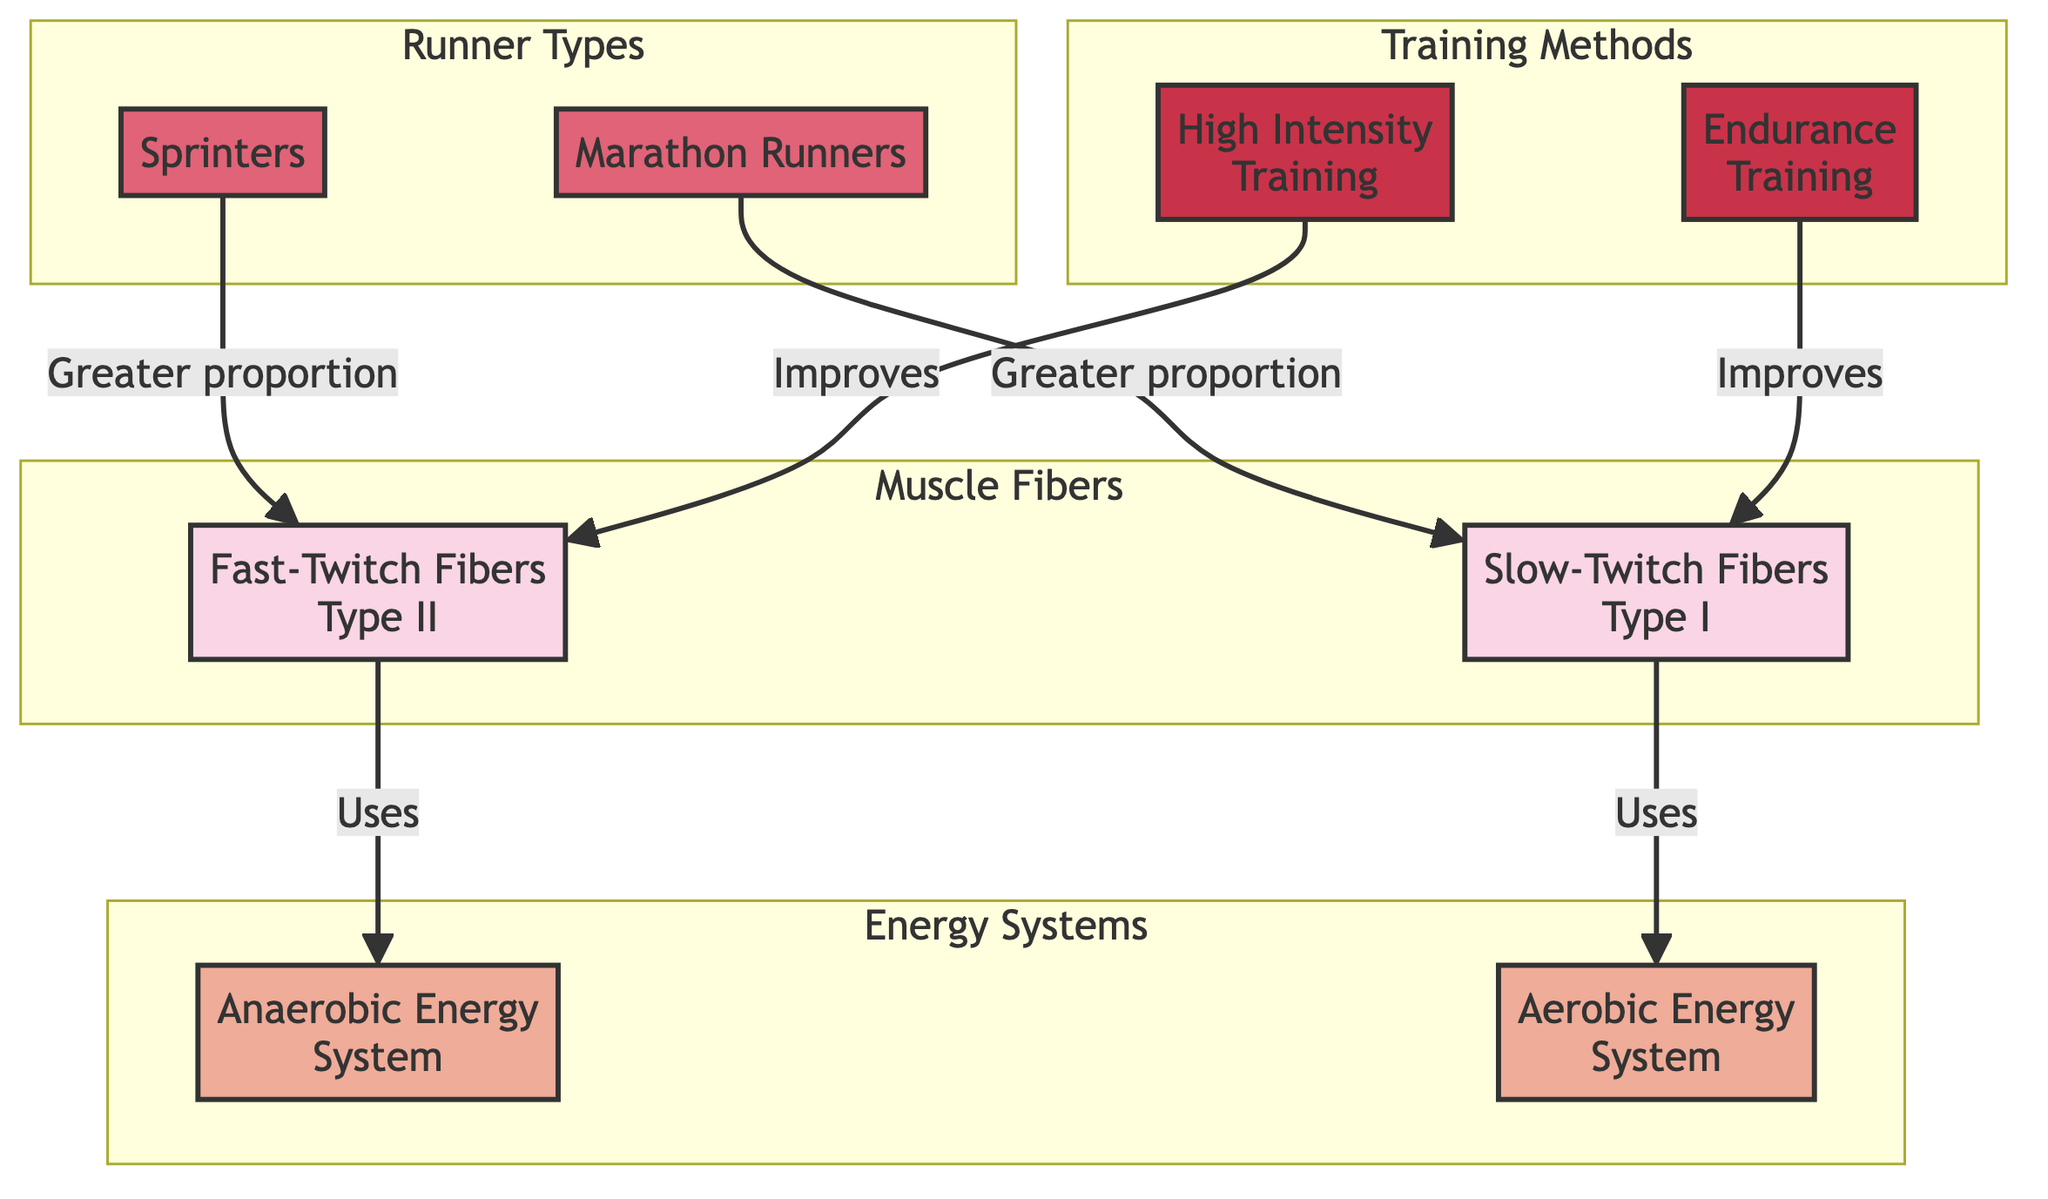What type of muscle fibers do sprinters predominantly use? According to the diagram, sprinters are linked to fast-twitch fibers, indicating they have a greater proportion of these fibers compared to other types.
Answer: Fast-Twitch Fibers Which energy system do slow-twitch fibers utilize? The diagram directly connects slow-twitch fibers to the aerobic energy system, showing that these muscle fibers rely on aerobic metabolism for energy.
Answer: Aerobic Energy System How do high-intensity training methods affect fast-twitch fibers? Based on the flow in the diagram, high-intensity training is shown to improve fast-twitch fibers, indicating that this type of training enhances their performance.
Answer: Improves What is the relationship between marathon runners and muscle fiber type? The diagram illustrates that marathon runners have a greater proportion of slow-twitch fibers, signifying that endurance athletes predominantly utilize these fibers.
Answer: Greater proportion of Slow-Twitch Fibers Which training method enhances slow-twitch fibers? The diagram links endurance training as the method that improves slow-twitch fibers, emphasizing its significance for endurance performance.
Answer: Endurance Training How many fiber types are represented in the diagram? The diagram includes two distinct types of muscle fibers, fast-twitch and slow-twitch, showing a clear classification.
Answer: Two What is the energy system associated with fast-twitch muscle fibers? Fast-twitch fibers are associated with the anaerobic energy system, as demonstrated by their direct link in the diagram.
Answer: Anaerobic Energy System What type of training is most beneficial for sprinters? The diagram indicates that sprinters benefit most from high-intensity training, suggesting it is key to enhancing their performance and muscle fiber composition.
Answer: High Intensity Training What do the dashed lines between the nodes signify in the diagram? In this diagram type, dashed lines typically represent connections or relationships between different categories, such as fibers, energy systems, runners, and training methods.
Answer: Relationships 